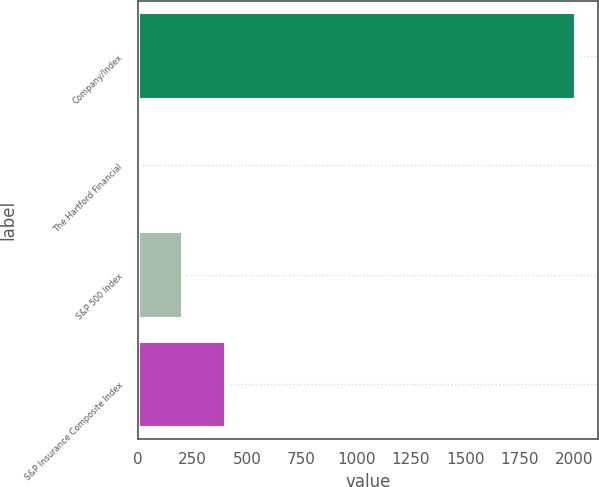Convert chart to OTSL. <chart><loc_0><loc_0><loc_500><loc_500><bar_chart><fcel>Company/Index<fcel>The Hartford Financial<fcel>S&P 500 Index<fcel>S&P Insurance Composite Index<nl><fcel>2007<fcel>4.55<fcel>204.8<fcel>405.05<nl></chart> 